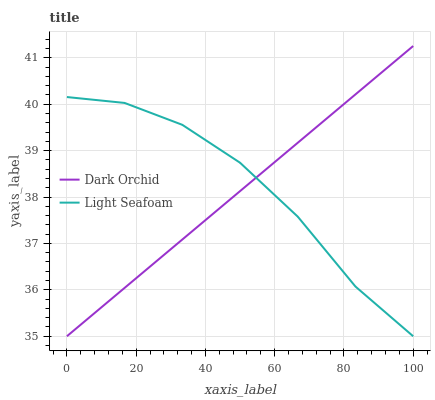Does Dark Orchid have the minimum area under the curve?
Answer yes or no. Yes. Does Light Seafoam have the maximum area under the curve?
Answer yes or no. Yes. Does Dark Orchid have the maximum area under the curve?
Answer yes or no. No. Is Dark Orchid the smoothest?
Answer yes or no. Yes. Is Light Seafoam the roughest?
Answer yes or no. Yes. Is Dark Orchid the roughest?
Answer yes or no. No. Does Light Seafoam have the lowest value?
Answer yes or no. Yes. Does Dark Orchid have the highest value?
Answer yes or no. Yes. Does Dark Orchid intersect Light Seafoam?
Answer yes or no. Yes. Is Dark Orchid less than Light Seafoam?
Answer yes or no. No. Is Dark Orchid greater than Light Seafoam?
Answer yes or no. No. 